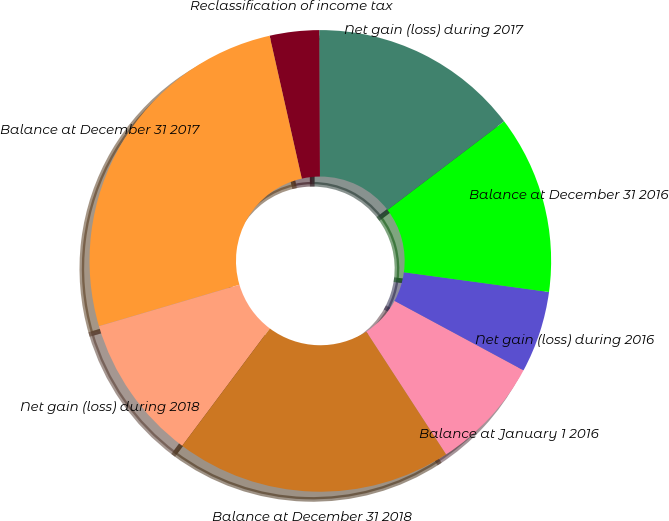Convert chart. <chart><loc_0><loc_0><loc_500><loc_500><pie_chart><fcel>Balance at January 1 2016<fcel>Net gain (loss) during 2016<fcel>Balance at December 31 2016<fcel>Net gain (loss) during 2017<fcel>Reclassification of income tax<fcel>Balance at December 31 2017<fcel>Net gain (loss) during 2018<fcel>Balance at December 31 2018<nl><fcel>7.97%<fcel>5.71%<fcel>12.49%<fcel>14.74%<fcel>3.45%<fcel>26.04%<fcel>10.23%<fcel>19.38%<nl></chart> 